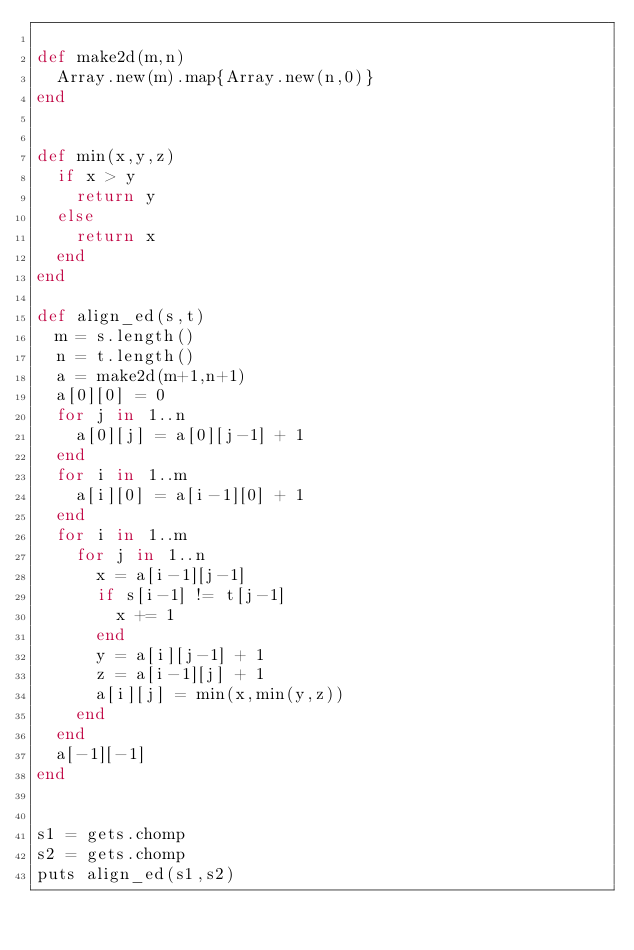Convert code to text. <code><loc_0><loc_0><loc_500><loc_500><_Ruby_>
def make2d(m,n)
  Array.new(m).map{Array.new(n,0)}
end


def min(x,y,z)
  if x > y
    return y
  else
    return x
  end
end

def align_ed(s,t)
  m = s.length()
  n = t.length()
  a = make2d(m+1,n+1)
  a[0][0] = 0
  for j in 1..n
    a[0][j] = a[0][j-1] + 1
  end
  for i in 1..m
    a[i][0] = a[i-1][0] + 1
  end
  for i in 1..m 
    for j in 1..n
      x = a[i-1][j-1]
      if s[i-1] != t[j-1]
        x += 1
      end
      y = a[i][j-1] + 1                         
      z = a[i-1][j] + 1
      a[i][j] = min(x,min(y,z))
    end
  end
  a[-1][-1]
end


s1 = gets.chomp
s2 = gets.chomp
puts align_ed(s1,s2)</code> 